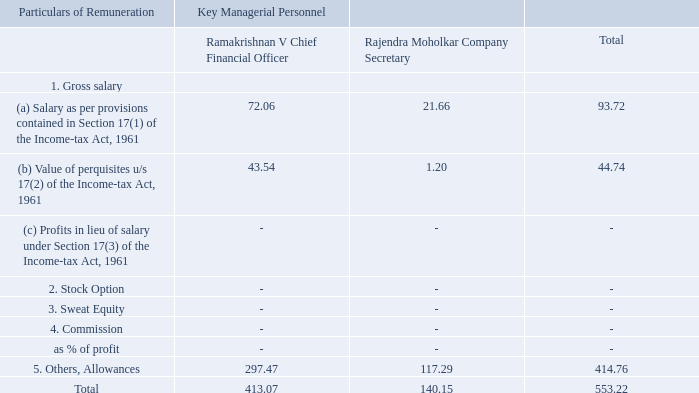C. Remuneration to Key Managerial Personnel other than MD / Manager / WTD
Note: For more information, please refer to the Corporate Governance Report.
Who has a higher gross salary? Ramakrishnan v chief financial officer. What is the value of Stock Option given to the Company Secretary? 0. What is the value of Commission given to the Chief Financial Officer? 0. What is the difference in Others, Allowances between the CFO and Company Secretary? 297.47-117.29 
Answer: 180.18. What is the CFO's remuneration as a percentage of the total given to them both?
Answer scale should be: percent. 413.07/553.22 
Answer: 74.67. What is the difference in total gross salary of the CFO and Company Secretary? 72.06+43.54-21.66-1.2 
Answer: 92.74. 